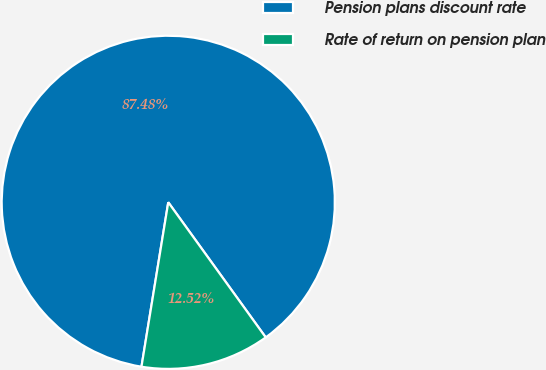Convert chart. <chart><loc_0><loc_0><loc_500><loc_500><pie_chart><fcel>Pension plans discount rate<fcel>Rate of return on pension plan<nl><fcel>87.48%<fcel>12.52%<nl></chart> 